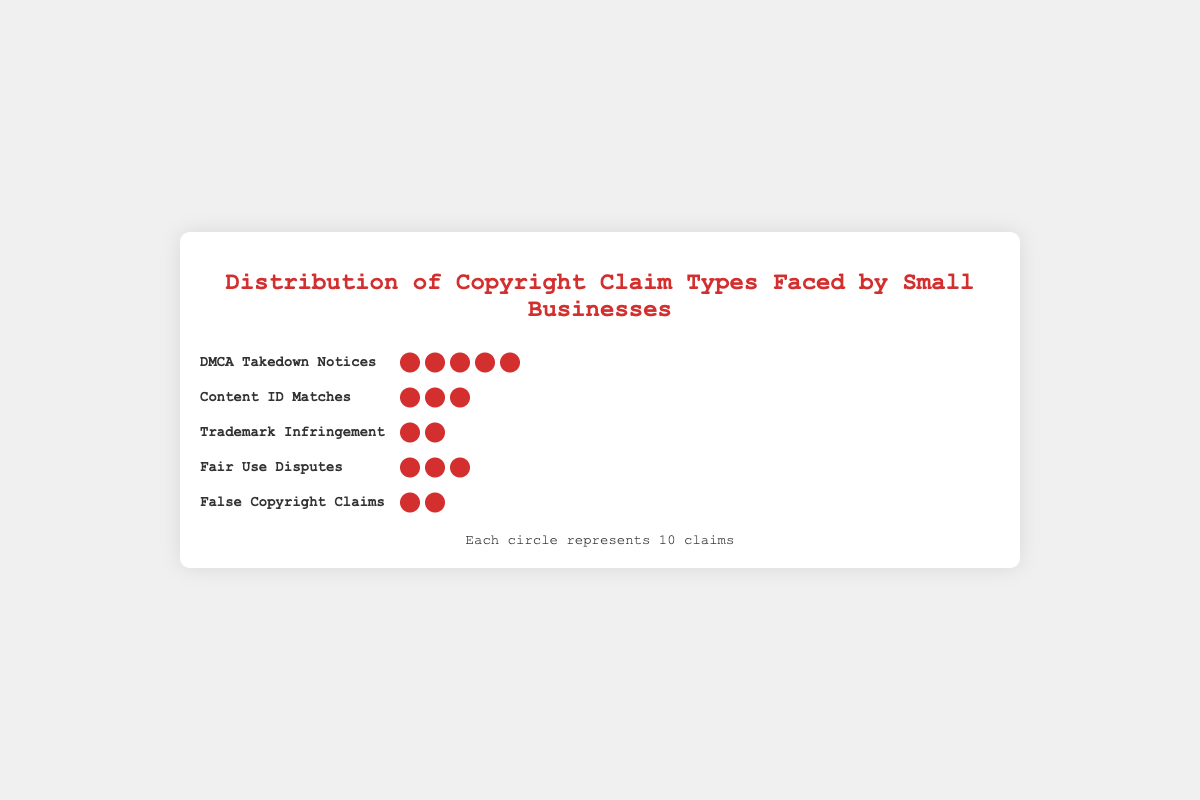What is the most common type of copyright claim? The figure shows that "DMCA Takedown Notices" has the highest number of icons representing claims. This type has 5 circles, where each circle represents 10 claims, summing up to 50 claims.
Answer: DMCA Takedown Notices Which type of copyright claim is the least frequent? The least frequent type can be determined by looking at the number of icons for each type. "Trademark Infringement" has the least with 1.5 circles, representing 15 claims.
Answer: Trademark Infringement How many total copyright claims are represented in the isotype plot? Summing up all claims from each type: 50 (DMCA Takedown Notices) + 30 (Content ID Matches) + 15 (Trademark Infringement) + 25 (Fair Use Disputes) + 20 (False Copyright Claims) = 140
Answer: 140 How many more DMCA Takedown Notices are there compared to False Copyright Claims? DMCA Takedown Notices have 50 claims and False Copyright Claims have 20 claims. The difference is 50 - 20 = 30.
Answer: 30 What percentage of the total claims are Fair Use Disputes? First, calculate the total number of claims which is 140. Fair Use Disputes have 25 claims. The percentage is (25 / 140) * 100 ≈ 17.86%.
Answer: 17.86% Are there more Content ID Matches or False Copyright Claims? The figure shows that Content ID Matches have 30 claims (3 circles), while False Copyright Claims have 20 claims (2 circles). Therefore, there are more Content ID Matches.
Answer: Content ID Matches If each DMCA Takedown Notice circle was divided into quarters, how many quarters would represent the total DMCA Takedown Notices? Each DMCA Takedown Notice circle represents 10 claims. There are 5 circles, equating to 50 claims. If each circle is divided into 4 quarters, there would be 4 quarters per circle. Hence, 5 circles * 4 quarters = 20 quarters.
Answer: 20 What is the combined total of Content ID Matches and Fair Use Disputes? Content ID Matches have 30 claims and Fair Use Disputes have 25 claims. Their combined total is 30 + 25 = 55.
Answer: 55 